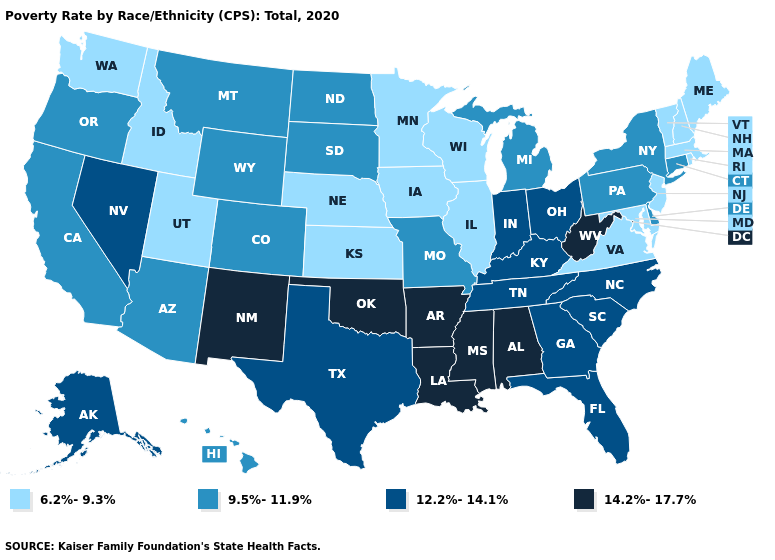Name the states that have a value in the range 14.2%-17.7%?
Give a very brief answer. Alabama, Arkansas, Louisiana, Mississippi, New Mexico, Oklahoma, West Virginia. Name the states that have a value in the range 14.2%-17.7%?
Short answer required. Alabama, Arkansas, Louisiana, Mississippi, New Mexico, Oklahoma, West Virginia. Name the states that have a value in the range 9.5%-11.9%?
Answer briefly. Arizona, California, Colorado, Connecticut, Delaware, Hawaii, Michigan, Missouri, Montana, New York, North Dakota, Oregon, Pennsylvania, South Dakota, Wyoming. Among the states that border Louisiana , does Texas have the lowest value?
Write a very short answer. Yes. What is the value of North Carolina?
Be succinct. 12.2%-14.1%. Does Arizona have the lowest value in the West?
Keep it brief. No. Among the states that border New Hampshire , which have the lowest value?
Quick response, please. Maine, Massachusetts, Vermont. Name the states that have a value in the range 6.2%-9.3%?
Be succinct. Idaho, Illinois, Iowa, Kansas, Maine, Maryland, Massachusetts, Minnesota, Nebraska, New Hampshire, New Jersey, Rhode Island, Utah, Vermont, Virginia, Washington, Wisconsin. Name the states that have a value in the range 14.2%-17.7%?
Be succinct. Alabama, Arkansas, Louisiana, Mississippi, New Mexico, Oklahoma, West Virginia. Which states have the lowest value in the USA?
Give a very brief answer. Idaho, Illinois, Iowa, Kansas, Maine, Maryland, Massachusetts, Minnesota, Nebraska, New Hampshire, New Jersey, Rhode Island, Utah, Vermont, Virginia, Washington, Wisconsin. What is the value of Nevada?
Concise answer only. 12.2%-14.1%. Name the states that have a value in the range 9.5%-11.9%?
Short answer required. Arizona, California, Colorado, Connecticut, Delaware, Hawaii, Michigan, Missouri, Montana, New York, North Dakota, Oregon, Pennsylvania, South Dakota, Wyoming. Name the states that have a value in the range 6.2%-9.3%?
Give a very brief answer. Idaho, Illinois, Iowa, Kansas, Maine, Maryland, Massachusetts, Minnesota, Nebraska, New Hampshire, New Jersey, Rhode Island, Utah, Vermont, Virginia, Washington, Wisconsin. Name the states that have a value in the range 14.2%-17.7%?
Write a very short answer. Alabama, Arkansas, Louisiana, Mississippi, New Mexico, Oklahoma, West Virginia. What is the value of West Virginia?
Write a very short answer. 14.2%-17.7%. 